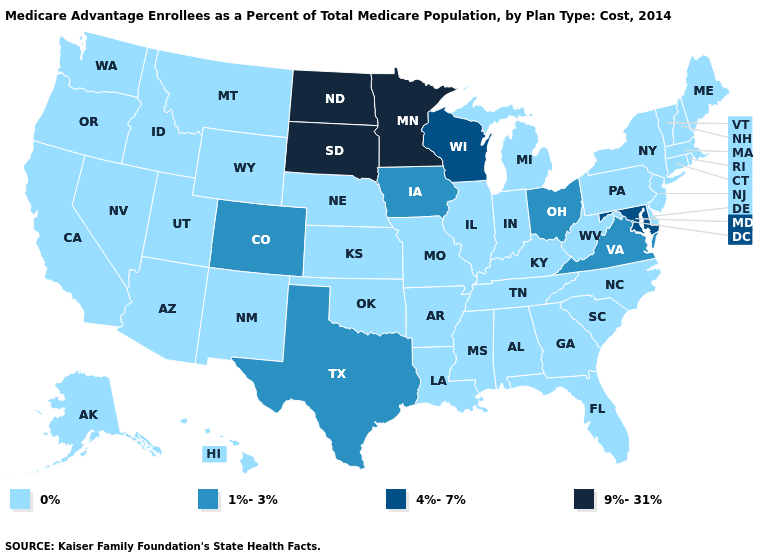Which states hav the highest value in the Northeast?
Be succinct. Connecticut, Massachusetts, Maine, New Hampshire, New Jersey, New York, Pennsylvania, Rhode Island, Vermont. Does Maryland have the lowest value in the South?
Write a very short answer. No. Is the legend a continuous bar?
Keep it brief. No. Is the legend a continuous bar?
Short answer required. No. Name the states that have a value in the range 1%-3%?
Concise answer only. Colorado, Iowa, Ohio, Texas, Virginia. Name the states that have a value in the range 9%-31%?
Give a very brief answer. Minnesota, North Dakota, South Dakota. Is the legend a continuous bar?
Quick response, please. No. Does the first symbol in the legend represent the smallest category?
Quick response, please. Yes. Does Colorado have the highest value in the West?
Keep it brief. Yes. Does North Dakota have the same value as Indiana?
Keep it brief. No. What is the highest value in the USA?
Concise answer only. 9%-31%. Name the states that have a value in the range 9%-31%?
Be succinct. Minnesota, North Dakota, South Dakota. Does the map have missing data?
Short answer required. No. Which states have the lowest value in the USA?
Keep it brief. Alaska, Alabama, Arkansas, Arizona, California, Connecticut, Delaware, Florida, Georgia, Hawaii, Idaho, Illinois, Indiana, Kansas, Kentucky, Louisiana, Massachusetts, Maine, Michigan, Missouri, Mississippi, Montana, North Carolina, Nebraska, New Hampshire, New Jersey, New Mexico, Nevada, New York, Oklahoma, Oregon, Pennsylvania, Rhode Island, South Carolina, Tennessee, Utah, Vermont, Washington, West Virginia, Wyoming. Name the states that have a value in the range 9%-31%?
Quick response, please. Minnesota, North Dakota, South Dakota. 